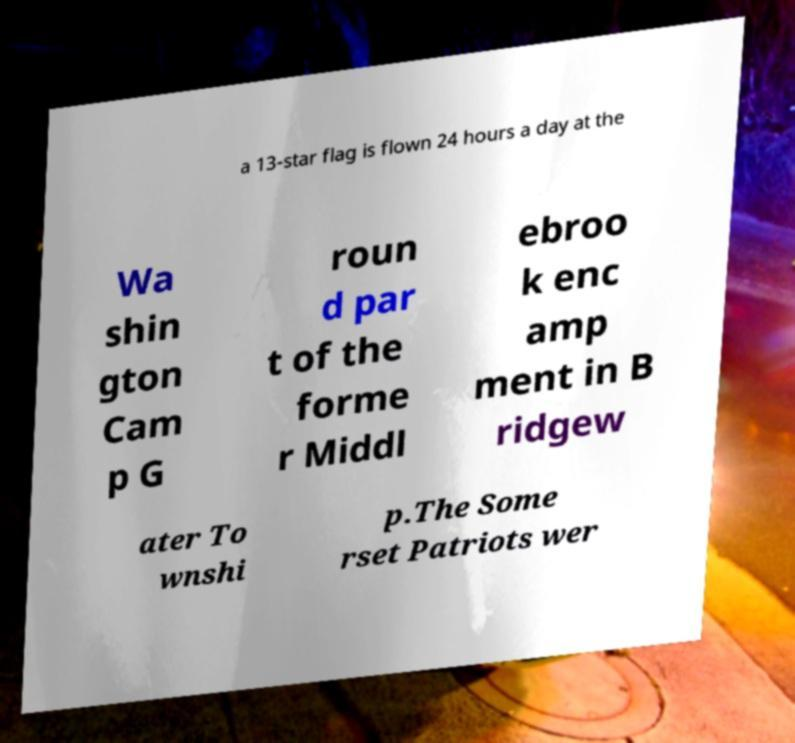For documentation purposes, I need the text within this image transcribed. Could you provide that? a 13-star flag is flown 24 hours a day at the Wa shin gton Cam p G roun d par t of the forme r Middl ebroo k enc amp ment in B ridgew ater To wnshi p.The Some rset Patriots wer 